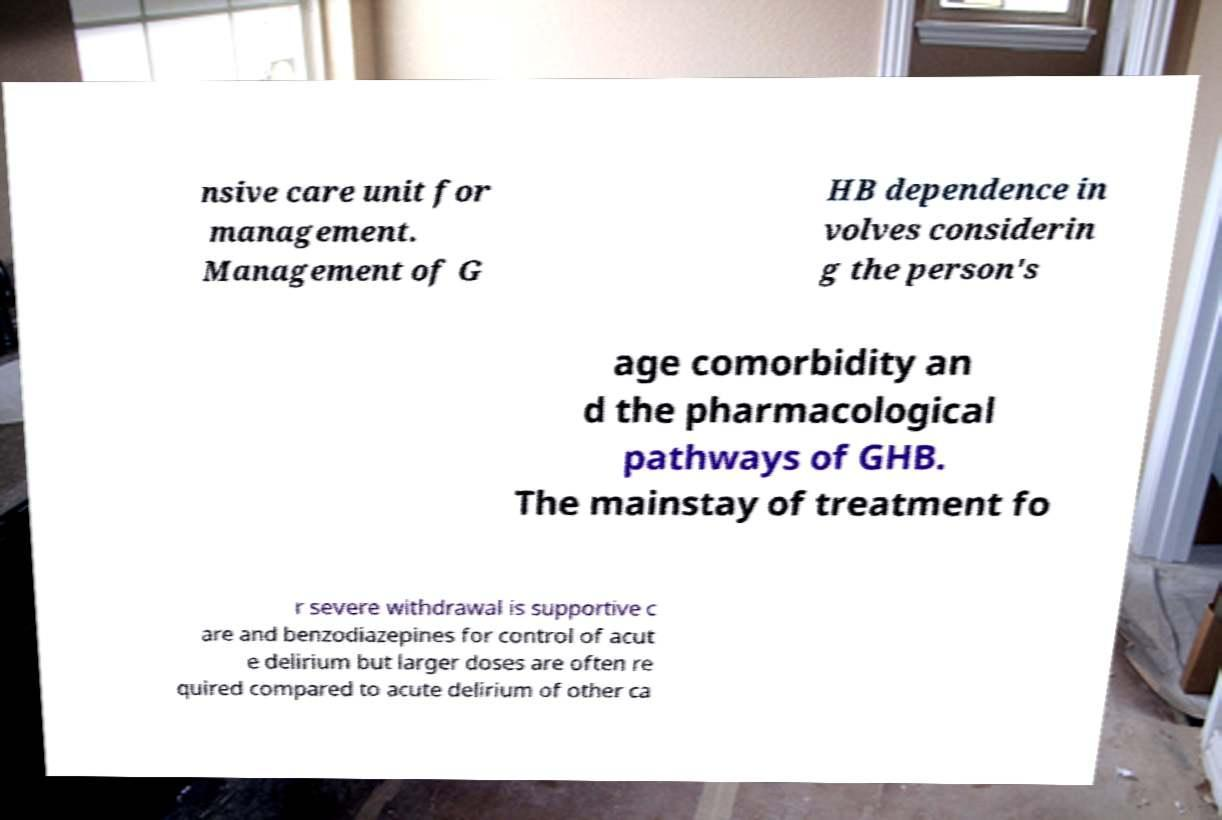Could you assist in decoding the text presented in this image and type it out clearly? nsive care unit for management. Management of G HB dependence in volves considerin g the person's age comorbidity an d the pharmacological pathways of GHB. The mainstay of treatment fo r severe withdrawal is supportive c are and benzodiazepines for control of acut e delirium but larger doses are often re quired compared to acute delirium of other ca 